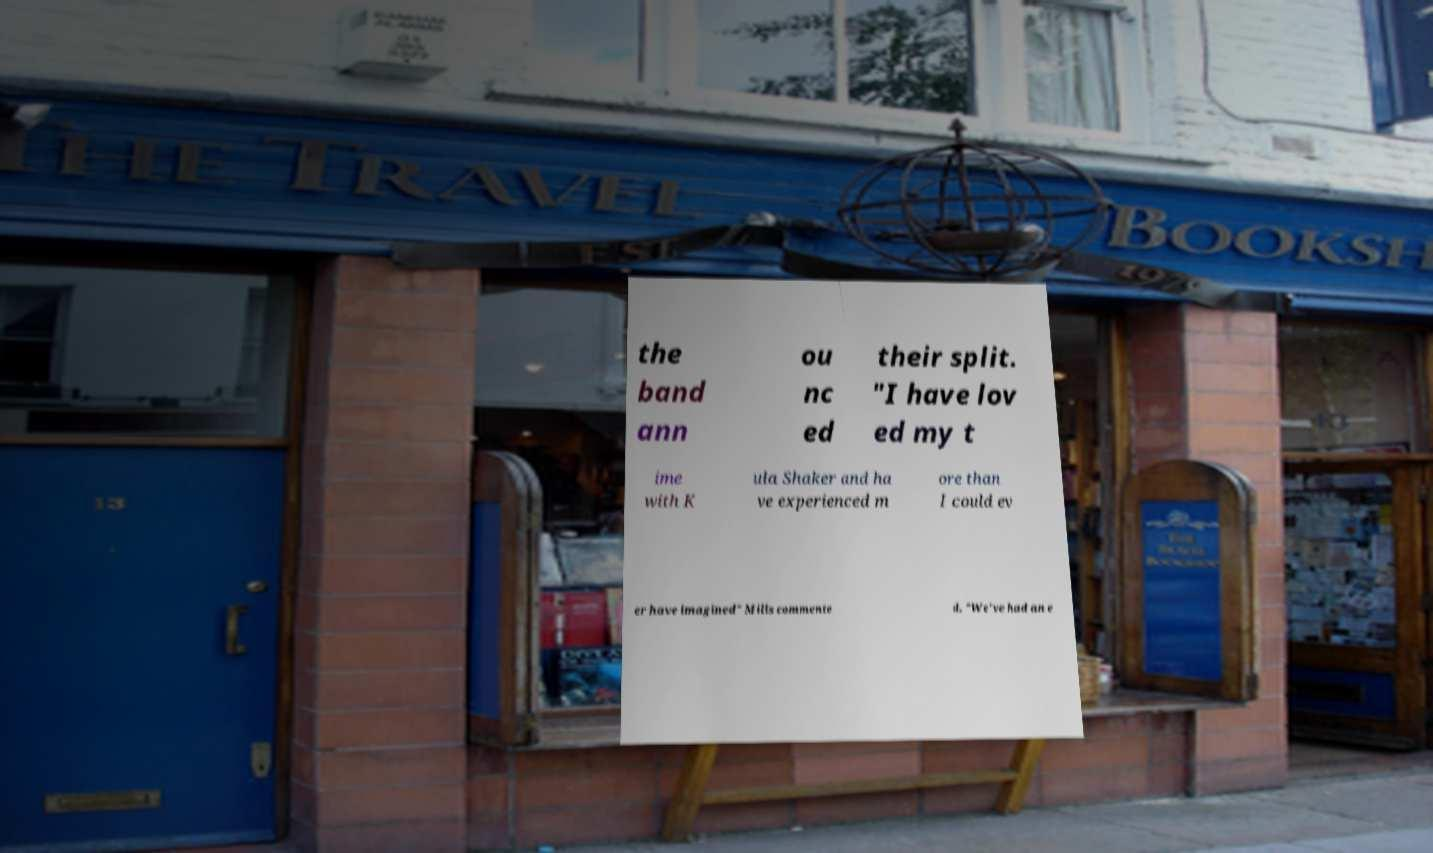Could you assist in decoding the text presented in this image and type it out clearly? the band ann ou nc ed their split. "I have lov ed my t ime with K ula Shaker and ha ve experienced m ore than I could ev er have imagined" Mills commente d. "We've had an e 